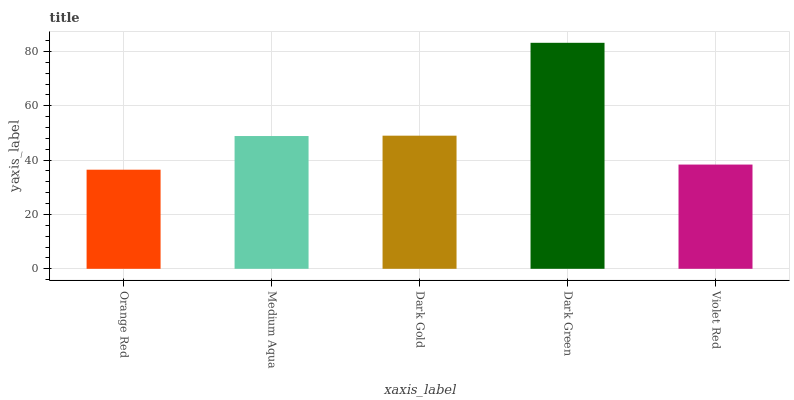Is Orange Red the minimum?
Answer yes or no. Yes. Is Dark Green the maximum?
Answer yes or no. Yes. Is Medium Aqua the minimum?
Answer yes or no. No. Is Medium Aqua the maximum?
Answer yes or no. No. Is Medium Aqua greater than Orange Red?
Answer yes or no. Yes. Is Orange Red less than Medium Aqua?
Answer yes or no. Yes. Is Orange Red greater than Medium Aqua?
Answer yes or no. No. Is Medium Aqua less than Orange Red?
Answer yes or no. No. Is Medium Aqua the high median?
Answer yes or no. Yes. Is Medium Aqua the low median?
Answer yes or no. Yes. Is Dark Green the high median?
Answer yes or no. No. Is Violet Red the low median?
Answer yes or no. No. 